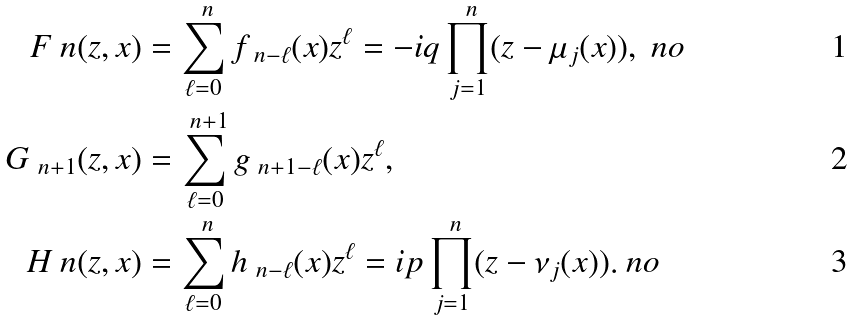<formula> <loc_0><loc_0><loc_500><loc_500>F _ { \ } n ( z , x ) & = \sum _ { \ell = 0 } ^ { \ n } f _ { \ n - \ell } ( x ) z ^ { \ell } = - i q \prod _ { j = 1 } ^ { \ n } ( z - \mu _ { j } ( x ) ) , \ n o \\ G _ { \ n + 1 } ( z , x ) & = \sum _ { \ell = 0 } ^ { \ n + 1 } g _ { \ n + 1 - \ell } ( x ) z ^ { \ell } , \\ H _ { \ } n ( z , x ) & = \sum _ { \ell = 0 } ^ { \ n } h _ { \ n - \ell } ( x ) z ^ { \ell } = i p \prod _ { j = 1 } ^ { \ n } ( z - \nu _ { j } ( x ) ) . \ n o</formula> 